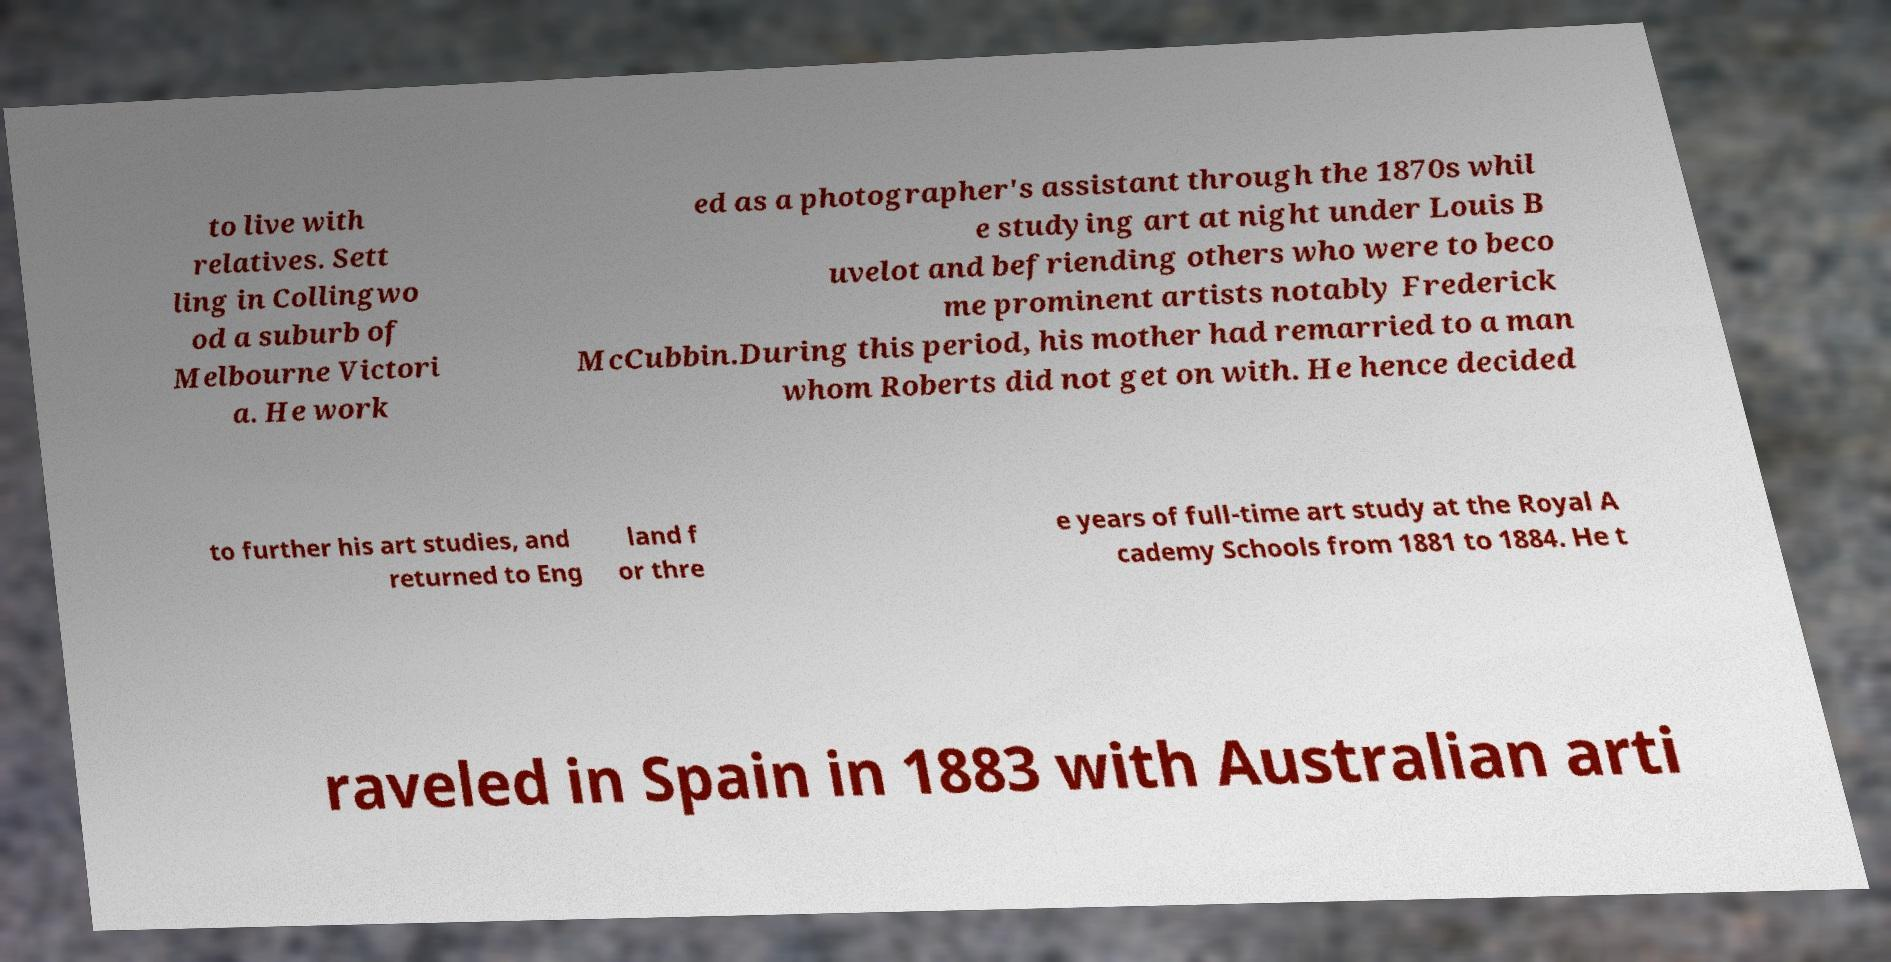Could you extract and type out the text from this image? to live with relatives. Sett ling in Collingwo od a suburb of Melbourne Victori a. He work ed as a photographer's assistant through the 1870s whil e studying art at night under Louis B uvelot and befriending others who were to beco me prominent artists notably Frederick McCubbin.During this period, his mother had remarried to a man whom Roberts did not get on with. He hence decided to further his art studies, and returned to Eng land f or thre e years of full-time art study at the Royal A cademy Schools from 1881 to 1884. He t raveled in Spain in 1883 with Australian arti 